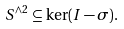Convert formula to latex. <formula><loc_0><loc_0><loc_500><loc_500>S ^ { \wedge 2 } \subseteq \ker ( I - \sigma ) .</formula> 